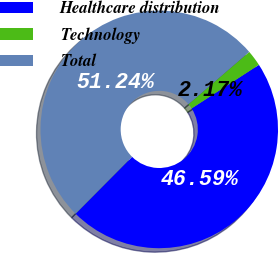<chart> <loc_0><loc_0><loc_500><loc_500><pie_chart><fcel>Healthcare distribution<fcel>Technology<fcel>Total<nl><fcel>46.59%<fcel>2.17%<fcel>51.25%<nl></chart> 